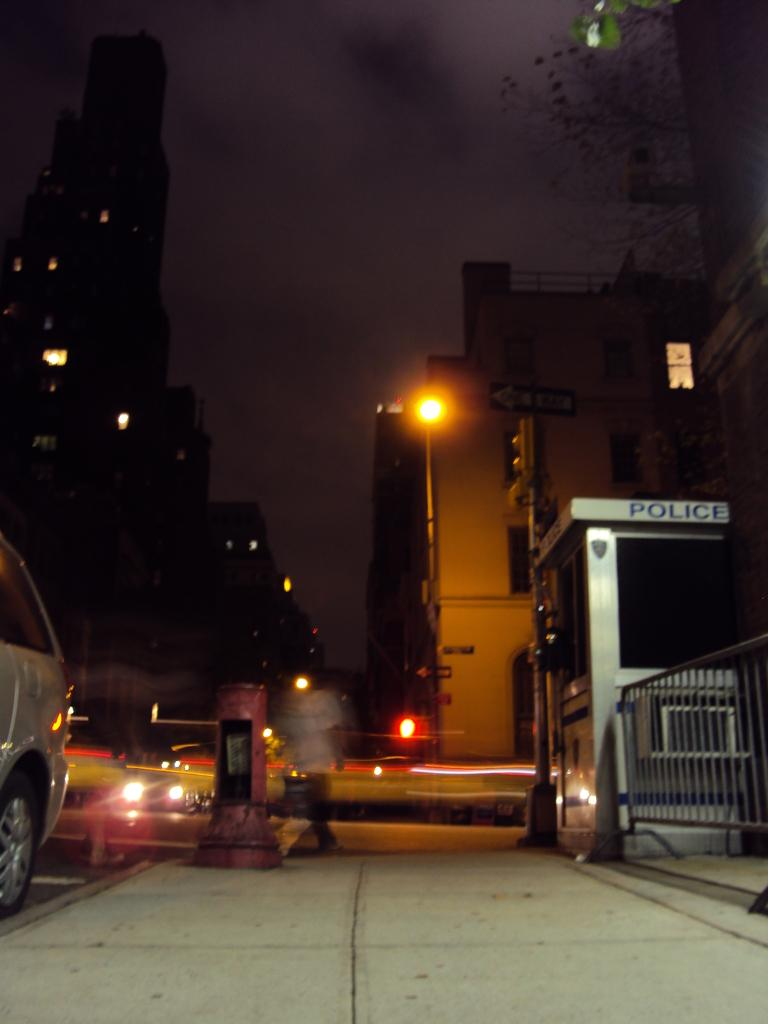What types of objects can be seen in the image? There are vehicles, metal rods, and a person in the image. What is the person in the image doing? The person is walking on a pathway. What can be seen in the background of the image? There are trees, buildings, lights, and poles visible in the background. What type of question is being asked by the person in the image? There is no indication in the image that the person is asking a question. Is there a tent visible in the image? No, there is no tent present in the image. 